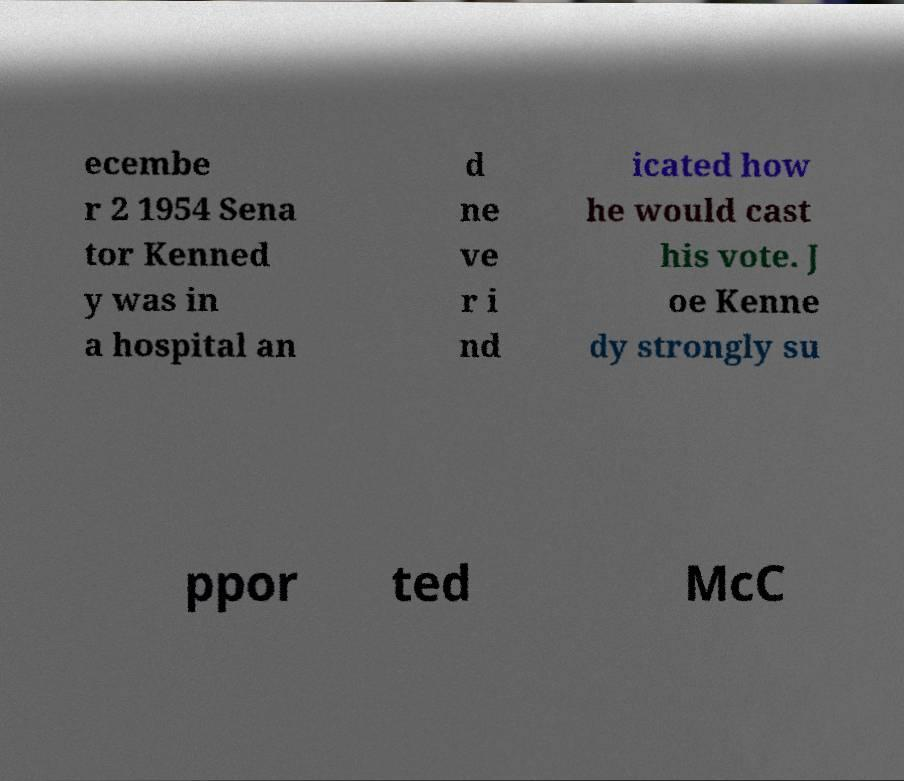What messages or text are displayed in this image? I need them in a readable, typed format. ecembe r 2 1954 Sena tor Kenned y was in a hospital an d ne ve r i nd icated how he would cast his vote. J oe Kenne dy strongly su ppor ted McC 